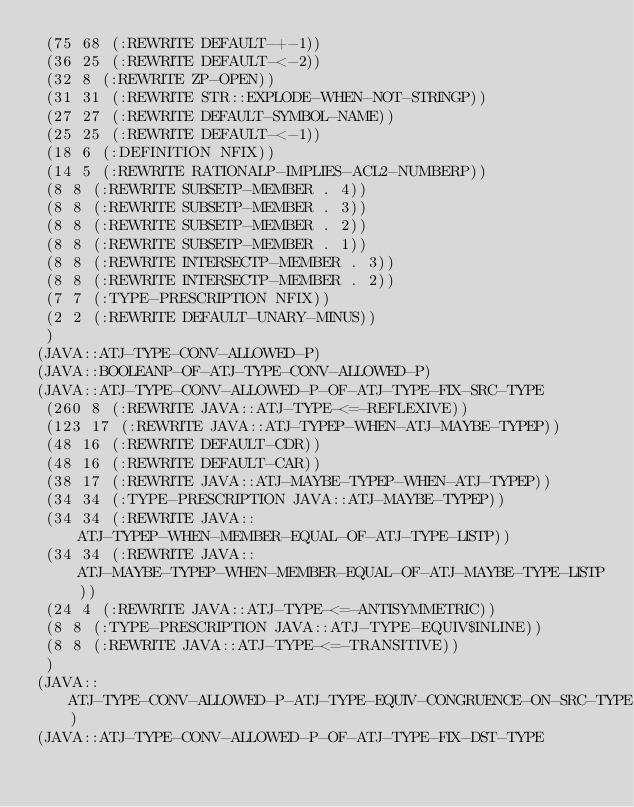<code> <loc_0><loc_0><loc_500><loc_500><_Lisp_> (75 68 (:REWRITE DEFAULT-+-1))
 (36 25 (:REWRITE DEFAULT-<-2))
 (32 8 (:REWRITE ZP-OPEN))
 (31 31 (:REWRITE STR::EXPLODE-WHEN-NOT-STRINGP))
 (27 27 (:REWRITE DEFAULT-SYMBOL-NAME))
 (25 25 (:REWRITE DEFAULT-<-1))
 (18 6 (:DEFINITION NFIX))
 (14 5 (:REWRITE RATIONALP-IMPLIES-ACL2-NUMBERP))
 (8 8 (:REWRITE SUBSETP-MEMBER . 4))
 (8 8 (:REWRITE SUBSETP-MEMBER . 3))
 (8 8 (:REWRITE SUBSETP-MEMBER . 2))
 (8 8 (:REWRITE SUBSETP-MEMBER . 1))
 (8 8 (:REWRITE INTERSECTP-MEMBER . 3))
 (8 8 (:REWRITE INTERSECTP-MEMBER . 2))
 (7 7 (:TYPE-PRESCRIPTION NFIX))
 (2 2 (:REWRITE DEFAULT-UNARY-MINUS))
 )
(JAVA::ATJ-TYPE-CONV-ALLOWED-P)
(JAVA::BOOLEANP-OF-ATJ-TYPE-CONV-ALLOWED-P)
(JAVA::ATJ-TYPE-CONV-ALLOWED-P-OF-ATJ-TYPE-FIX-SRC-TYPE
 (260 8 (:REWRITE JAVA::ATJ-TYPE-<=-REFLEXIVE))
 (123 17 (:REWRITE JAVA::ATJ-TYPEP-WHEN-ATJ-MAYBE-TYPEP))
 (48 16 (:REWRITE DEFAULT-CDR))
 (48 16 (:REWRITE DEFAULT-CAR))
 (38 17 (:REWRITE JAVA::ATJ-MAYBE-TYPEP-WHEN-ATJ-TYPEP))
 (34 34 (:TYPE-PRESCRIPTION JAVA::ATJ-MAYBE-TYPEP))
 (34 34 (:REWRITE JAVA::ATJ-TYPEP-WHEN-MEMBER-EQUAL-OF-ATJ-TYPE-LISTP))
 (34 34 (:REWRITE JAVA::ATJ-MAYBE-TYPEP-WHEN-MEMBER-EQUAL-OF-ATJ-MAYBE-TYPE-LISTP))
 (24 4 (:REWRITE JAVA::ATJ-TYPE-<=-ANTISYMMETRIC))
 (8 8 (:TYPE-PRESCRIPTION JAVA::ATJ-TYPE-EQUIV$INLINE))
 (8 8 (:REWRITE JAVA::ATJ-TYPE-<=-TRANSITIVE))
 )
(JAVA::ATJ-TYPE-CONV-ALLOWED-P-ATJ-TYPE-EQUIV-CONGRUENCE-ON-SRC-TYPE)
(JAVA::ATJ-TYPE-CONV-ALLOWED-P-OF-ATJ-TYPE-FIX-DST-TYPE</code> 